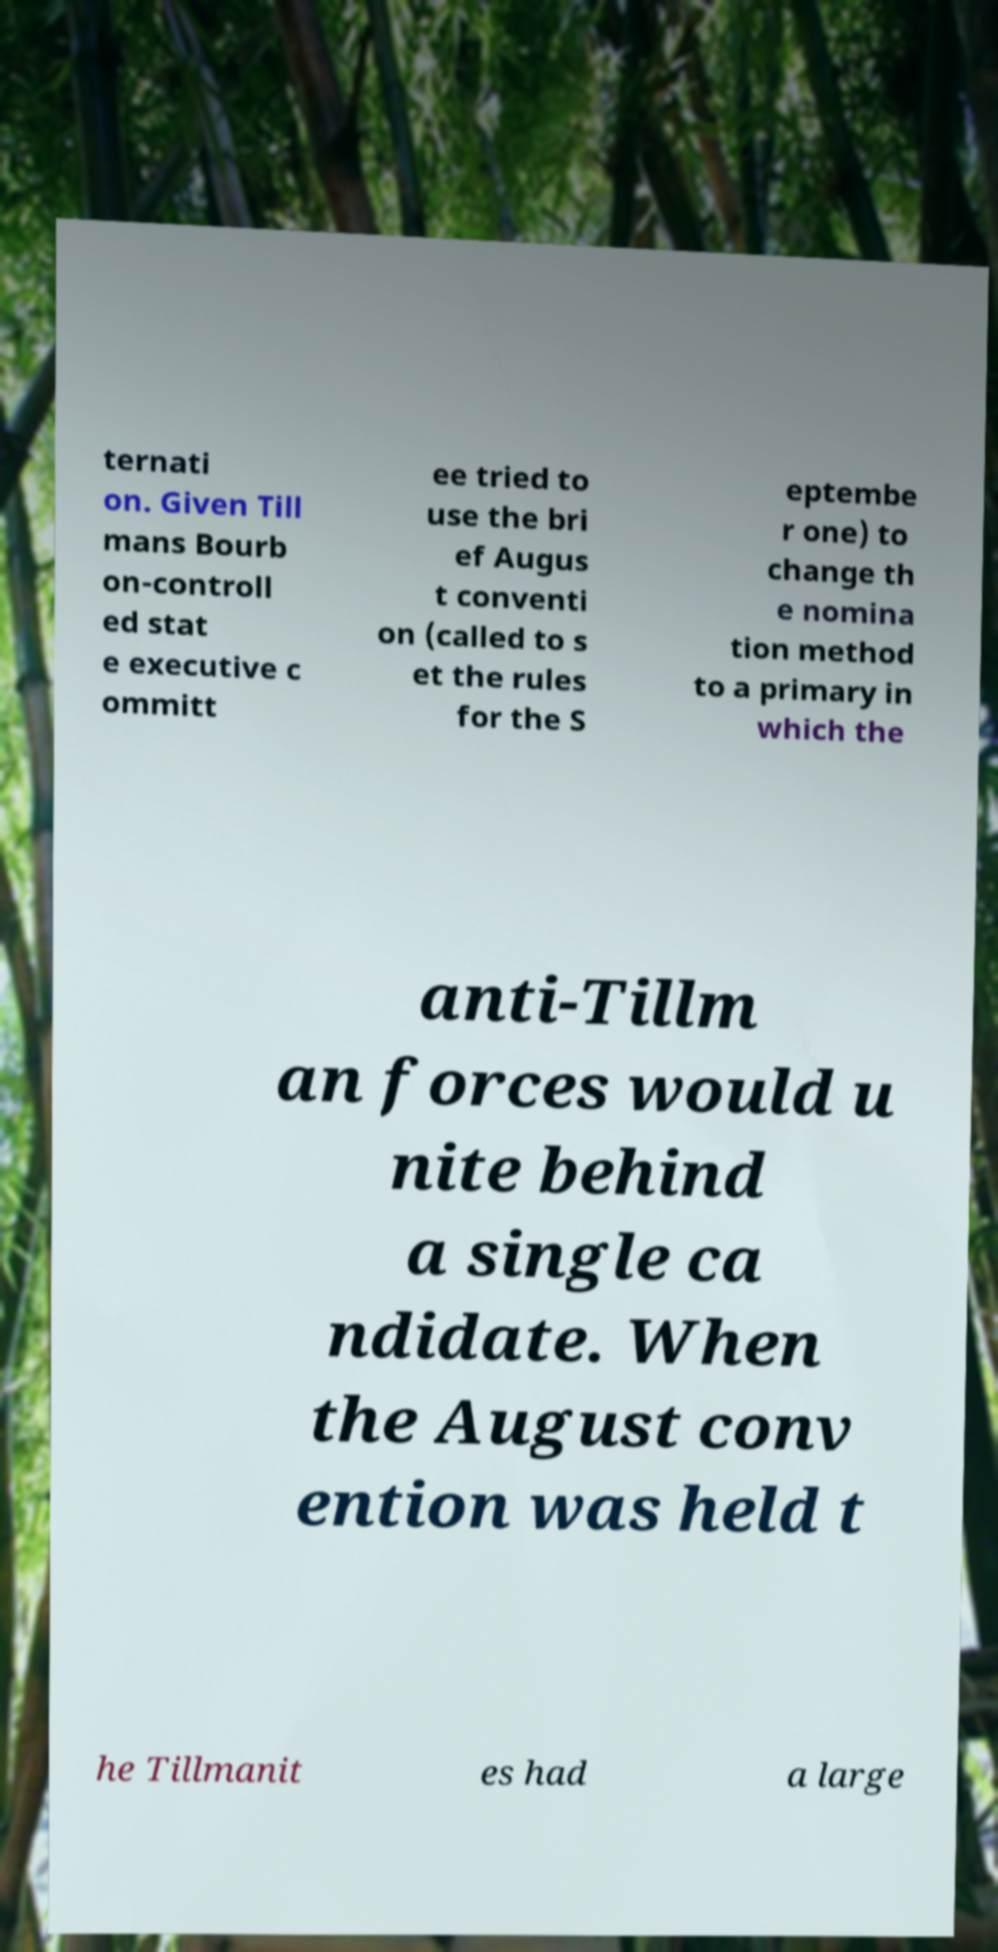Could you extract and type out the text from this image? ternati on. Given Till mans Bourb on-controll ed stat e executive c ommitt ee tried to use the bri ef Augus t conventi on (called to s et the rules for the S eptembe r one) to change th e nomina tion method to a primary in which the anti-Tillm an forces would u nite behind a single ca ndidate. When the August conv ention was held t he Tillmanit es had a large 